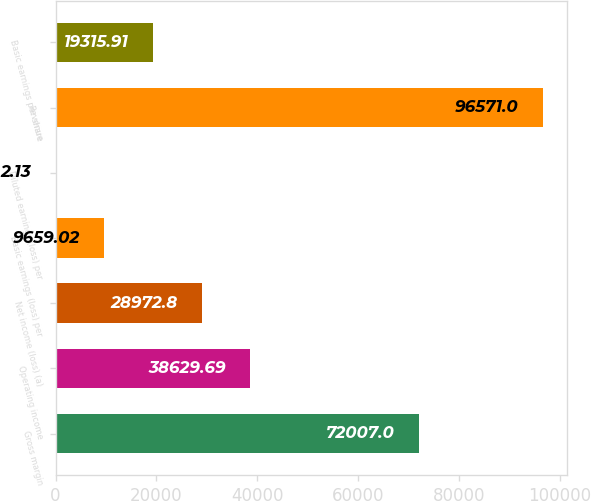Convert chart. <chart><loc_0><loc_0><loc_500><loc_500><bar_chart><fcel>Gross margin<fcel>Operating income<fcel>Net income (loss) (a)<fcel>Basic earnings (loss) per<fcel>Diluted earnings (loss) per<fcel>Revenue<fcel>Basic earnings per share<nl><fcel>72007<fcel>38629.7<fcel>28972.8<fcel>9659.02<fcel>2.13<fcel>96571<fcel>19315.9<nl></chart> 